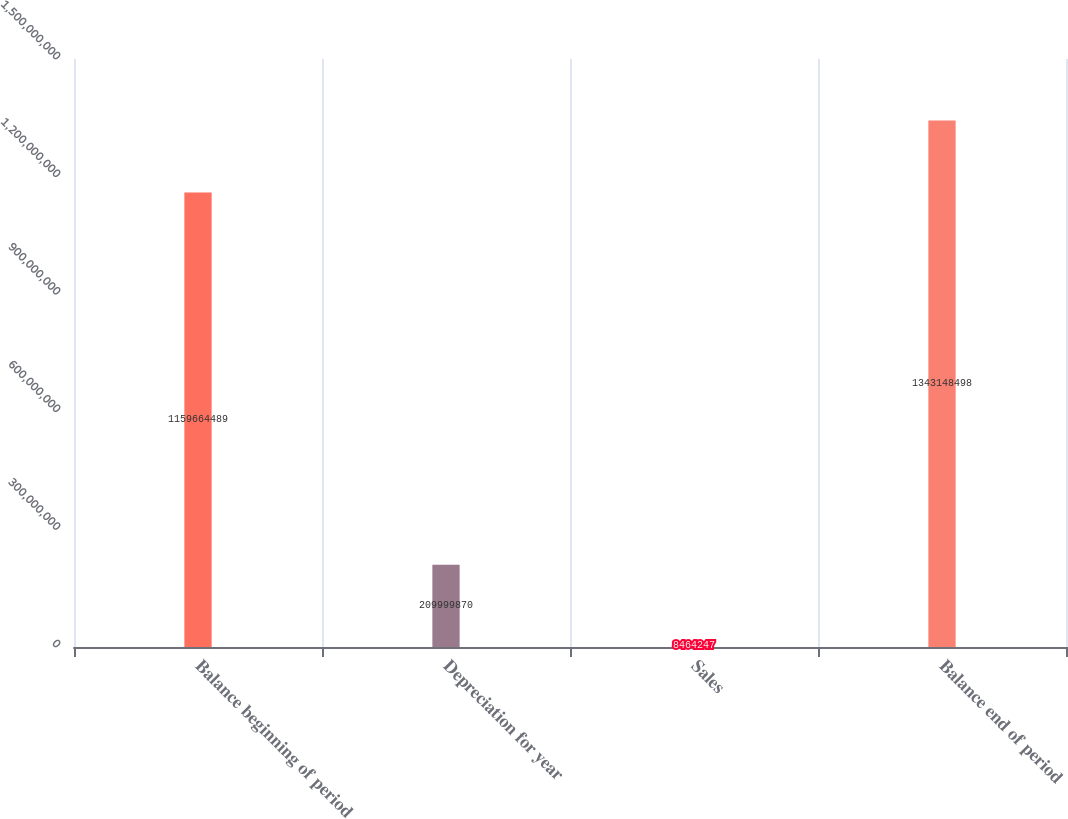<chart> <loc_0><loc_0><loc_500><loc_500><bar_chart><fcel>Balance beginning of period<fcel>Depreciation for year<fcel>Sales<fcel>Balance end of period<nl><fcel>1.15966e+09<fcel>2.1e+08<fcel>8.46425e+06<fcel>1.34315e+09<nl></chart> 